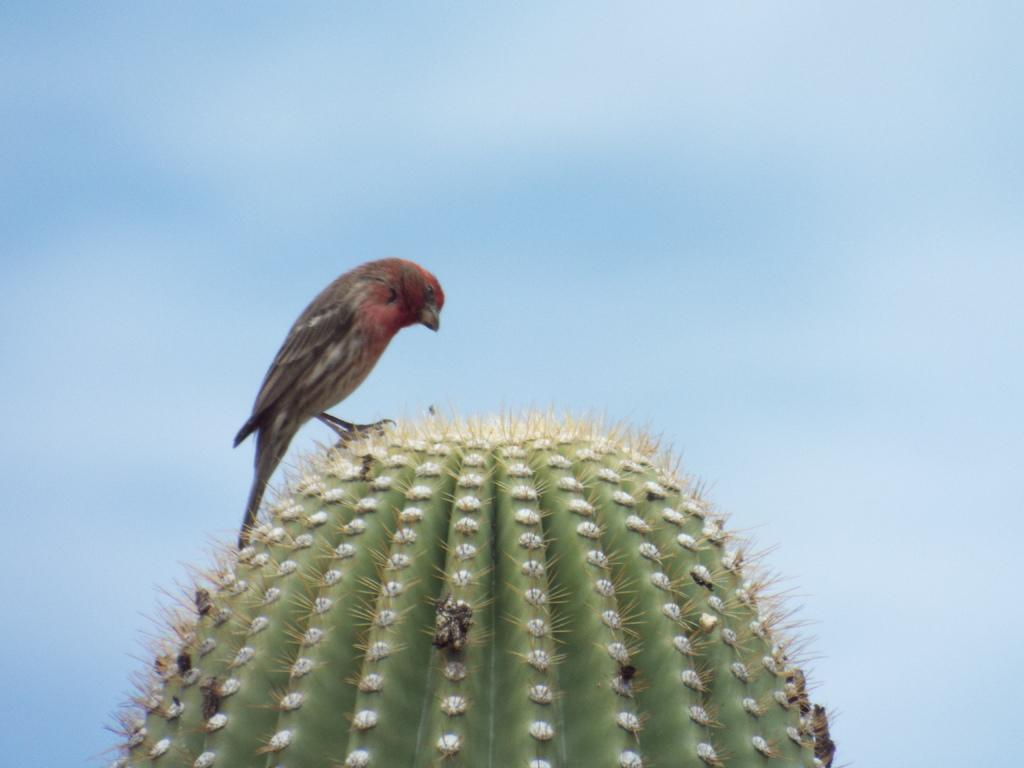What type of animal can be seen in the image? There is a bird in the image. Where is the bird located? The bird is on a cactus. What is the position of the bird and cactus in the image? The bird and cactus are in the center of the image. What type of haircut does the bird have in the image? There is no indication of a haircut in the image, as birds do not have hair. 